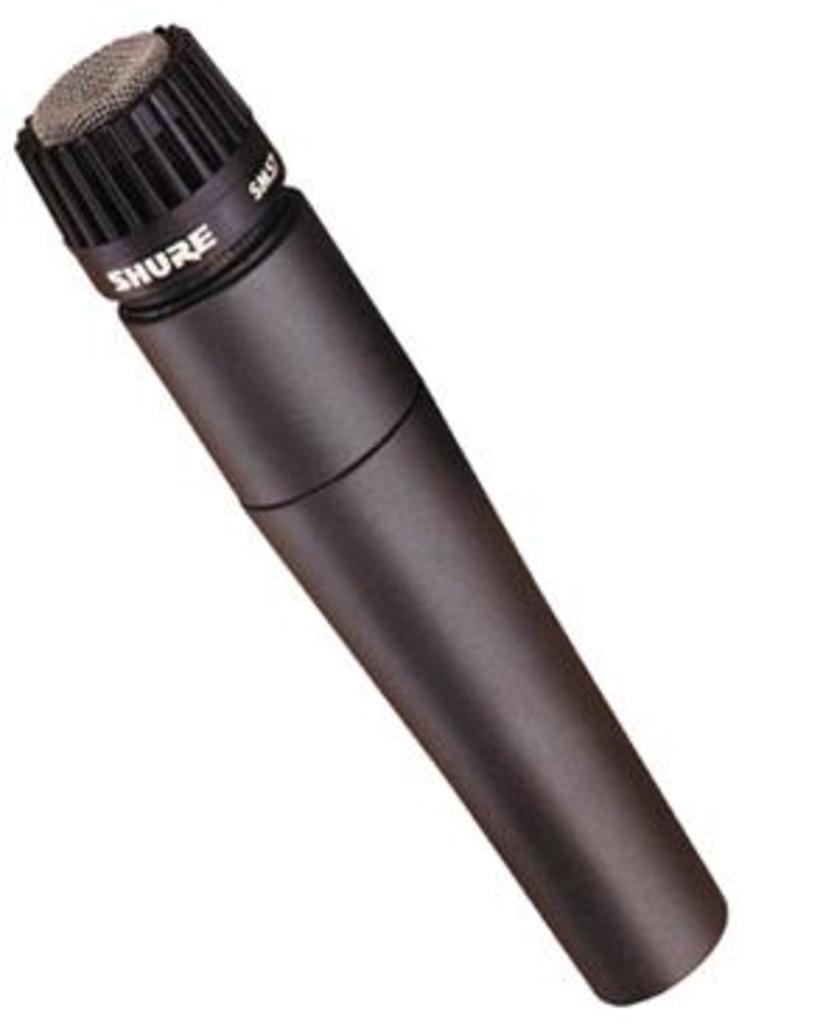How would you summarize this image in a sentence or two? In this image there is a mic. 